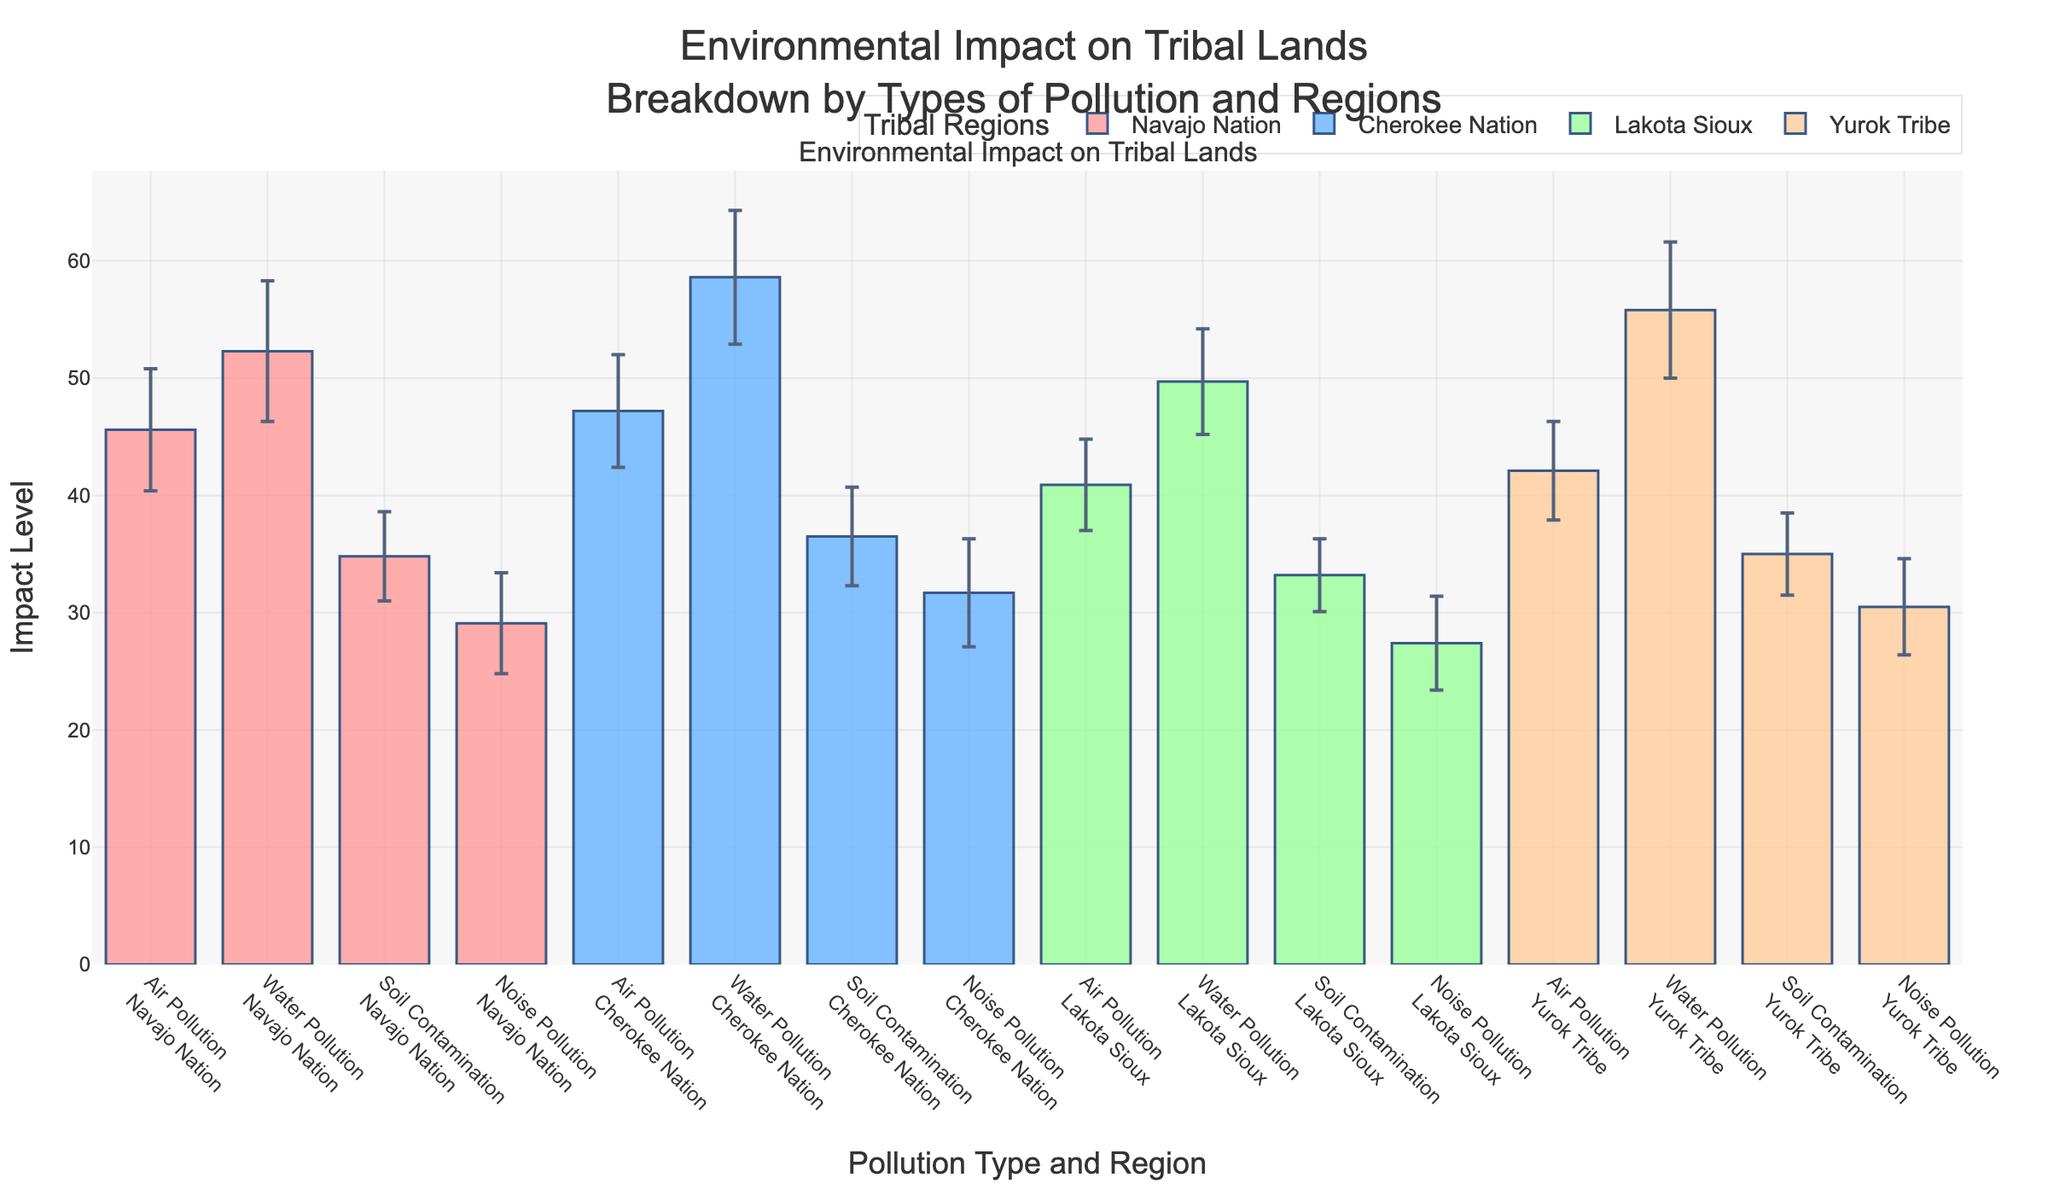What is the title of the figure? The title at the top of the figure mentions "Environmental Impact on Tribal Lands" followed by "Breakdown by Types of Pollution and Regions".
Answer: Environmental Impact on Tribal Lands - Breakdown by Types of Pollution and Regions Which region has the highest mean impact for water pollution? By looking at the heights of the bars for water pollution for each region, the bar for Cherokee Nation is the tallest.
Answer: Cherokee Nation What is the mean impact of soil contamination in the Lakota Sioux region? Locate the bar for soil contamination in the Lakota Sioux region and read the height of the bar.
Answer: 33.2 How does the mean impact of air pollution in the Navajo Nation compare to that in the Yurok Tribe? Compare the heights of the bars for air pollution in both the Navajo Nation and the Yurok Tribe to see which is higher.
Answer: 45.6 is higher than 42.1 What is the range of standard deviations for noise pollution across all regions? Identify the standard deviations for noise pollution in each region and find the minimum and maximum values.
Answer: 4.0 to 4.6 Which type of pollution has the lowest mean impact in the Cherokee Nation? Look at the bars for all pollution types within the Cherokee Nation and identify the shortest one.
Answer: Noise Pollution What is the average mean impact of air pollution across all regions? Add the mean impacts of air pollution across the four regions and divide by four. (45.6 + 47.2 + 40.9 + 42.1) / 4 = 43.95
Answer: 43.95 What is the difference in the mean impact of water pollution between the Navajo Nation and the Lakota Sioux? Subtract the mean impact of water pollution in the Lakota Sioux from that in the Navajo Nation. 52.3 - 49.7 = 2.6
Answer: 2.6 Which region exhibits the smallest variation in impact for soil contamination? Compare the standard deviations of soil contamination for each region and identify the smallest one.
Answer: Lakota Sioux What is the total mean impact of noise pollution across all regions combined? Add the mean impacts of noise pollution for all four regions. 29.1 + 31.7 + 27.4 + 30.5 = 118.7
Answer: 118.7 